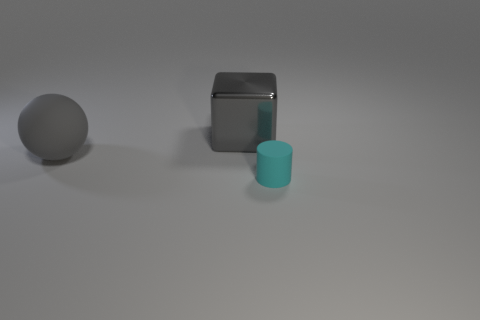Add 1 small gray metal objects. How many objects exist? 4 Subtract 1 balls. How many balls are left? 0 Subtract all cyan spheres. Subtract all cyan cubes. How many spheres are left? 1 Subtract all tiny rubber cylinders. Subtract all cyan things. How many objects are left? 1 Add 1 cyan objects. How many cyan objects are left? 2 Add 1 large purple objects. How many large purple objects exist? 1 Subtract 0 purple spheres. How many objects are left? 3 Subtract all cylinders. How many objects are left? 2 